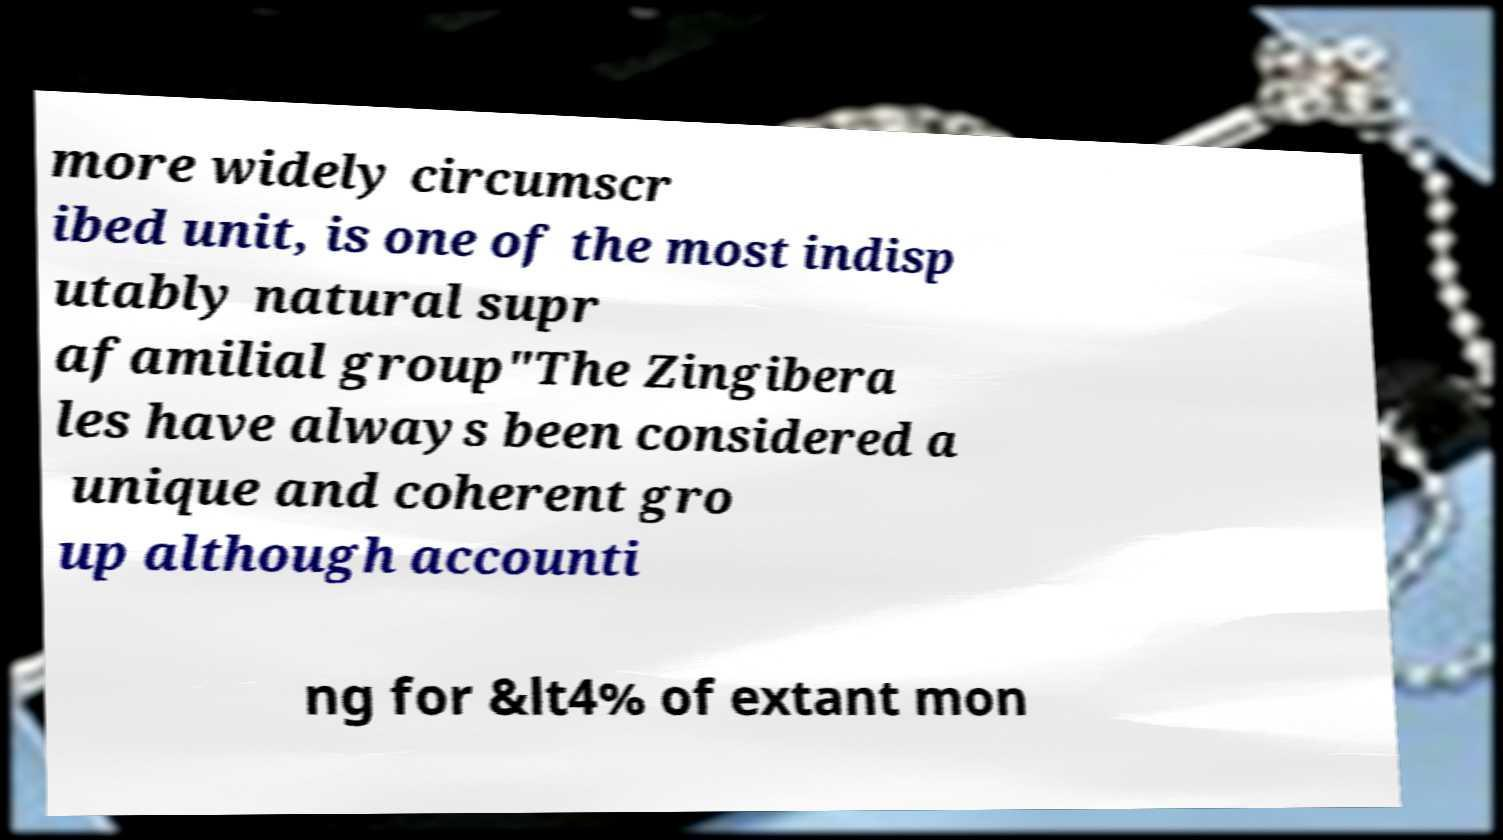What messages or text are displayed in this image? I need them in a readable, typed format. more widely circumscr ibed unit, is one of the most indisp utably natural supr afamilial group"The Zingibera les have always been considered a unique and coherent gro up although accounti ng for &lt4% of extant mon 